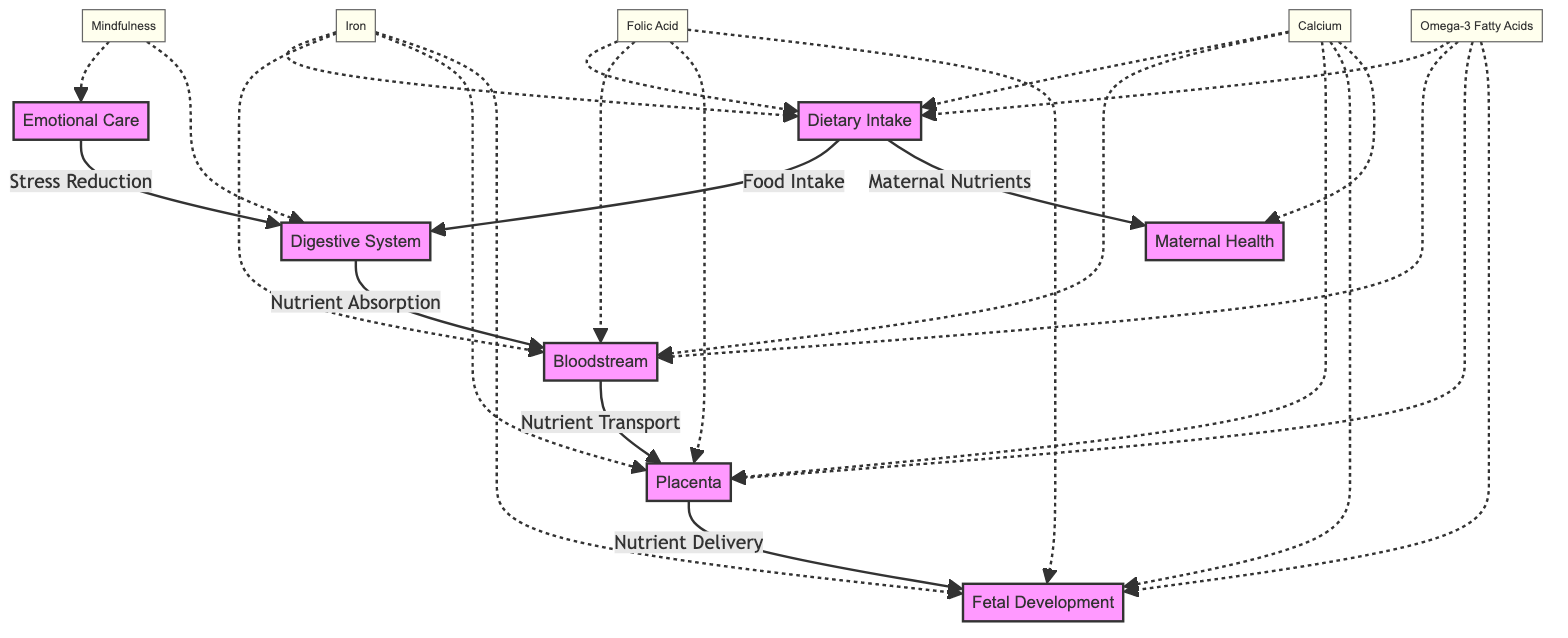What is the first step in nutrient flow during pregnancy? The diagram shows that the first step is Dietary Intake, indicating the starting point of the nutrient flow.
Answer: Dietary Intake How many key nutrients are indicated in the diagram? The diagram displays four key nutrients: Iron, Folic Acid, Calcium, and Omega-3 Fatty Acids, resulting in a total of four nutrients.
Answer: Four Which nutrient is connected to both Maternal Health and Fetal Development? Calcium is the nutrient that has connections to both Maternal Health and Fetal Development, as shown in the diagram.
Answer: Calcium What technique is featured to improve nutrient absorption through the digestive system? The diagram mentions "Mindfulness" as the technique for improving nutrient absorption via the digestive system by reducing stress.
Answer: Mindfulness How do nutrients reach the fetus according to the flow in the diagram? The nutrients reach the fetus through the Bloodstream and are transported to the Placenta for delivery to Fetal Development.
Answer: Bloodstream What role does emotional care play in nutrient absorption? Emotional care, indicated as "Stress Reduction," supports the digestive system by potentially improving nutrient absorption and overall maternal well-being.
Answer: Stress Reduction Which nutrient is specifically associated with Fetal Development for neurological support? The diagram displays Omega-3 Fatty Acids as a key nutrient specifically linked to Fetal Development for neurological support.
Answer: Omega-3 Fatty Acids How does 'Dietary Intake' influence 'Maternal Health'? Dietary Intake delivers essential nutrients to Maternal Health, ensuring that the mother receives the necessary vitamins and minerals needed during pregnancy.
Answer: Maternal Nutrients 